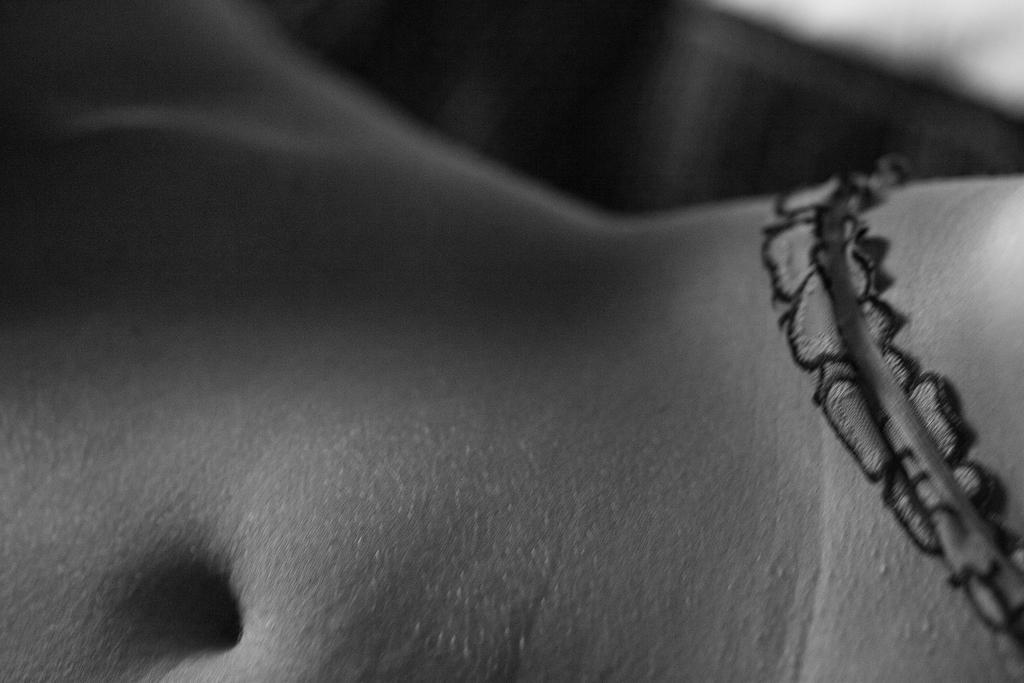Could you give a brief overview of what you see in this image? In this image, we can see a body with navel. Here there is a strip on the body. 